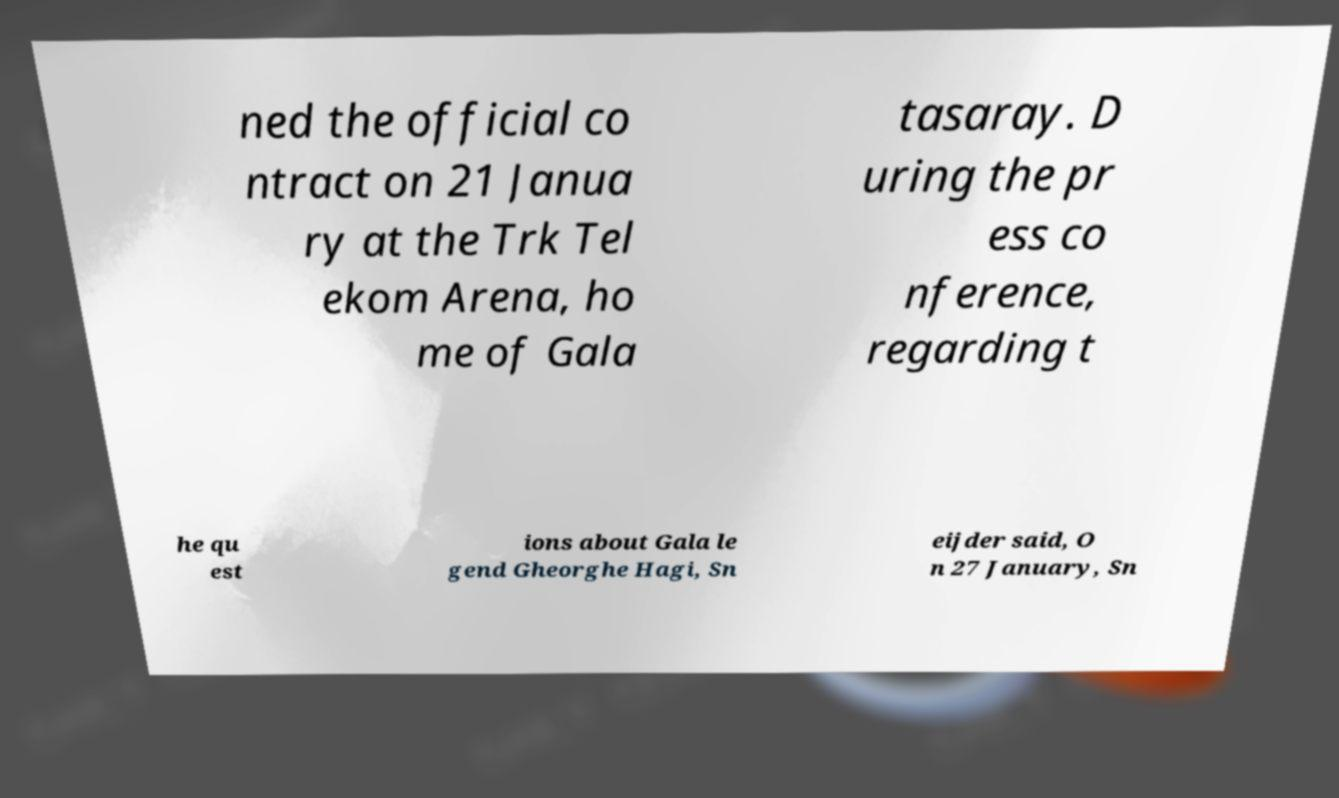What messages or text are displayed in this image? I need them in a readable, typed format. ned the official co ntract on 21 Janua ry at the Trk Tel ekom Arena, ho me of Gala tasaray. D uring the pr ess co nference, regarding t he qu est ions about Gala le gend Gheorghe Hagi, Sn eijder said, O n 27 January, Sn 